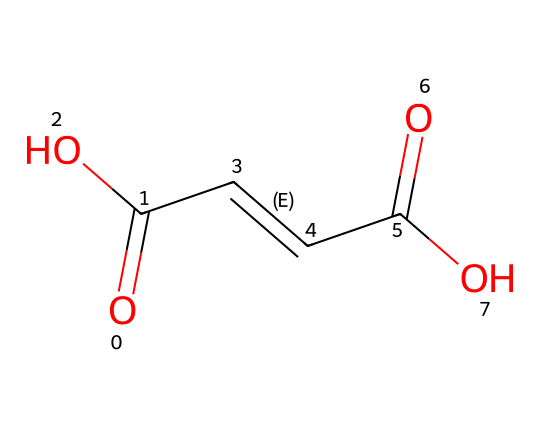What is the molecular formula of fumaric acid? The SMILES representation can be interpreted as follows: each 'C' represents a carbon atom, 'O' represents an oxygen atom, and 'H' is implied in saturation. Counting the carbon and oxygen gives two carbons and four oxygens, leading to the molecular formula C4H4O4.
Answer: C4H4O4 How many double bonds are present in fumaric acid? The SMILES structure contains the '/C=C/' notation, indicating a double bond between the two carbon atoms. Thus, there is one double bond in the molecule.
Answer: one What type of geometric isomerism is exhibited by fumaric acid? Fumaric acid displays cis-trans isomerism due to the presence of a double bond between the two carbon atoms, which restricts rotation and allows for different spatial arrangements of substituents.
Answer: cis-trans How many carbon atoms are in the longest carbon chain of fumaric acid? The SMILES representation shows a continuous chain of four carbon atoms before the branches start, making four the total in the longest carbon chain.
Answer: four What is the functional group present in fumaric acid that characterizes it as a dicarboxylic acid? The presence of two 'C(=O)O' functional groups indicates two carboxylic acid groups (–COOH) in the structure, which categorizes the molecule as a dicarboxylic acid.
Answer: carboxylic acid How many stereogenic centers are there in fumaric acid? The presence of the double bond between the two central carbon atoms, along with the different substituents around this bond, determines that there are two potential stereogenic centers, but in the case of fumaric acid, only one is significant due to symmetry, ultimately giving zero stereogenic centers that create distinct enantiomers.
Answer: zero 